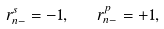<formula> <loc_0><loc_0><loc_500><loc_500>r _ { n - } ^ { s } = - 1 , \quad r _ { n - } ^ { p } = + 1 ,</formula> 